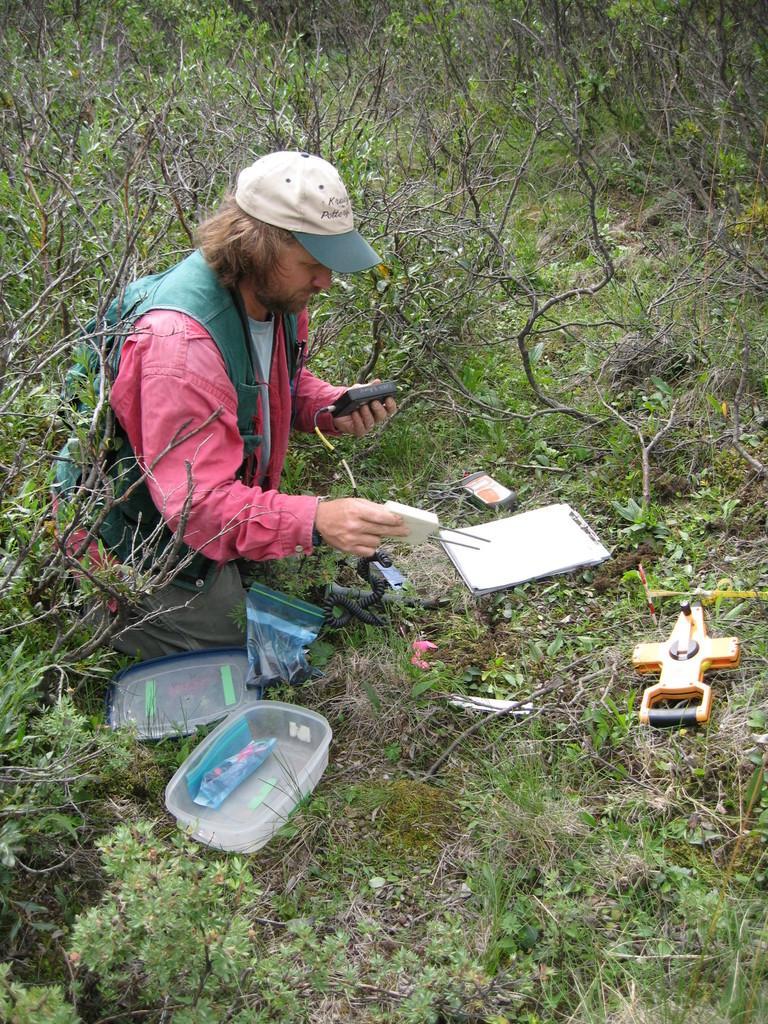In one or two sentences, can you explain what this image depicts? In this image there is a person holding two objects and sitting on his knees on the grass , and there are papers on a wooden plank, box, lid and some objects on the grass, plants. 